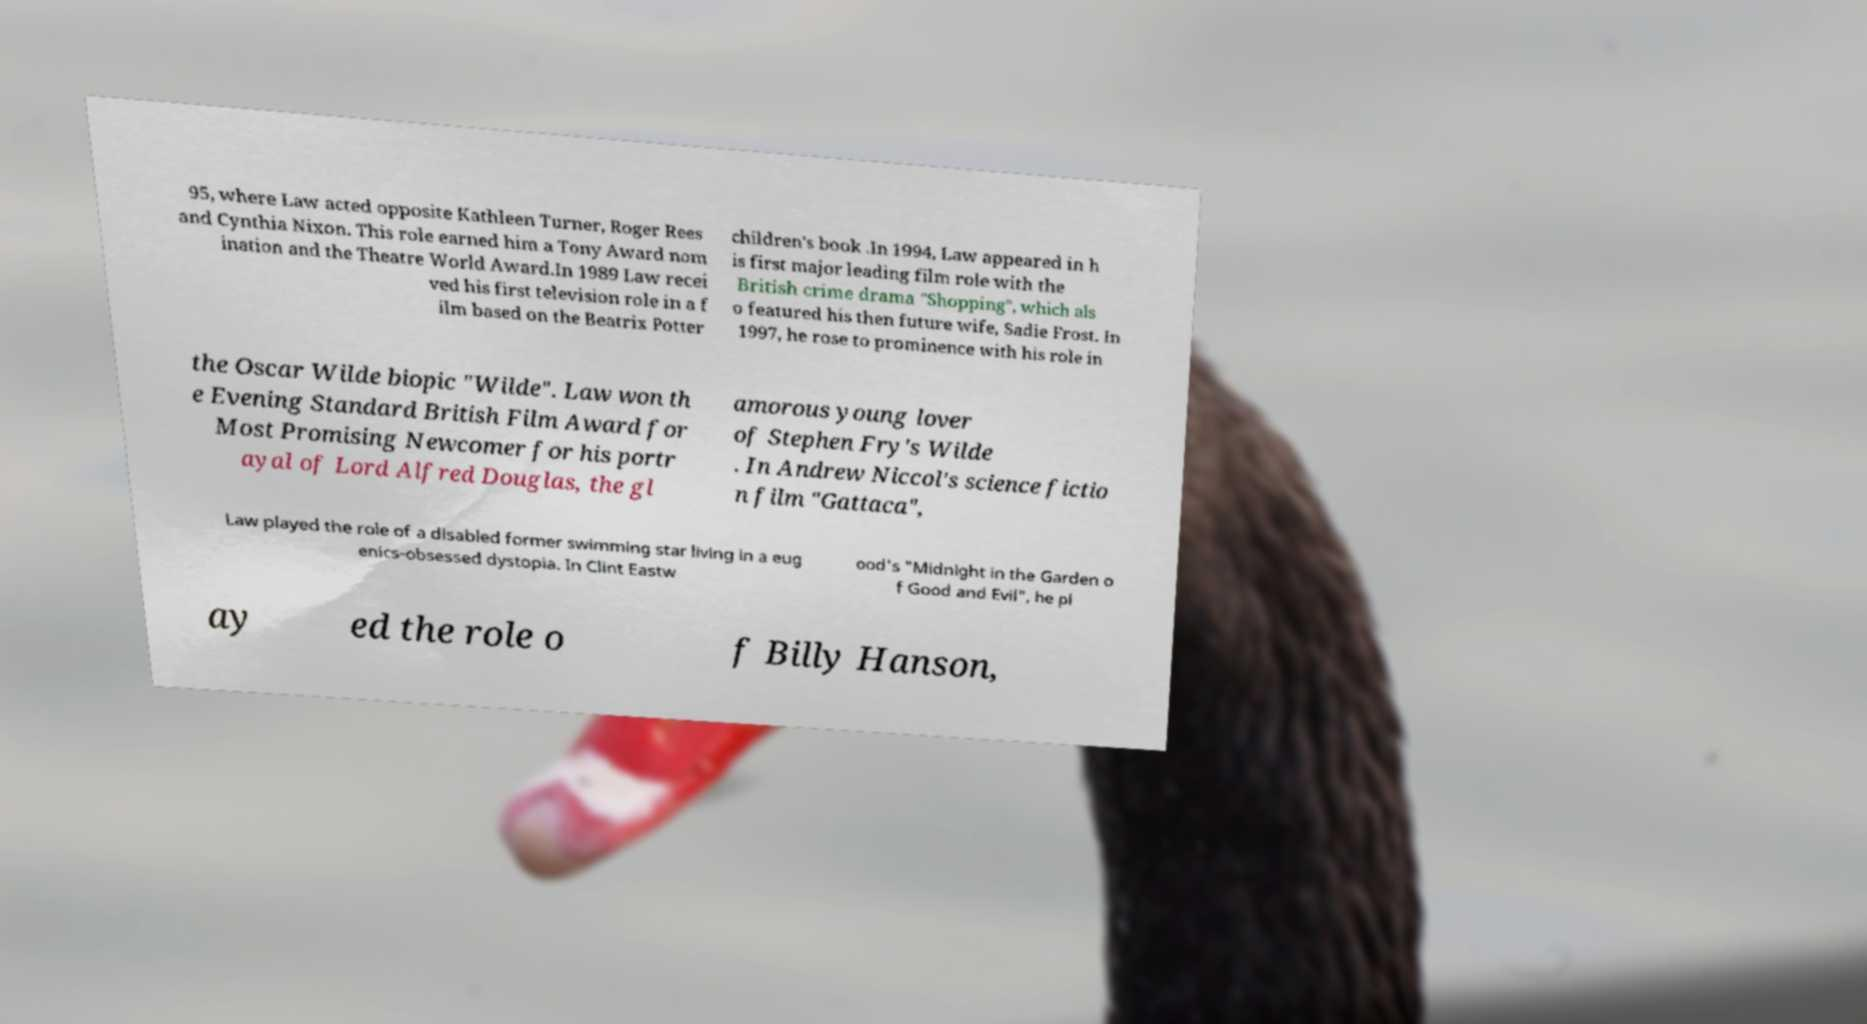Can you read and provide the text displayed in the image?This photo seems to have some interesting text. Can you extract and type it out for me? 95, where Law acted opposite Kathleen Turner, Roger Rees and Cynthia Nixon. This role earned him a Tony Award nom ination and the Theatre World Award.In 1989 Law recei ved his first television role in a f ilm based on the Beatrix Potter children's book .In 1994, Law appeared in h is first major leading film role with the British crime drama "Shopping", which als o featured his then future wife, Sadie Frost. In 1997, he rose to prominence with his role in the Oscar Wilde biopic "Wilde". Law won th e Evening Standard British Film Award for Most Promising Newcomer for his portr ayal of Lord Alfred Douglas, the gl amorous young lover of Stephen Fry's Wilde . In Andrew Niccol's science fictio n film "Gattaca", Law played the role of a disabled former swimming star living in a eug enics-obsessed dystopia. In Clint Eastw ood's "Midnight in the Garden o f Good and Evil", he pl ay ed the role o f Billy Hanson, 